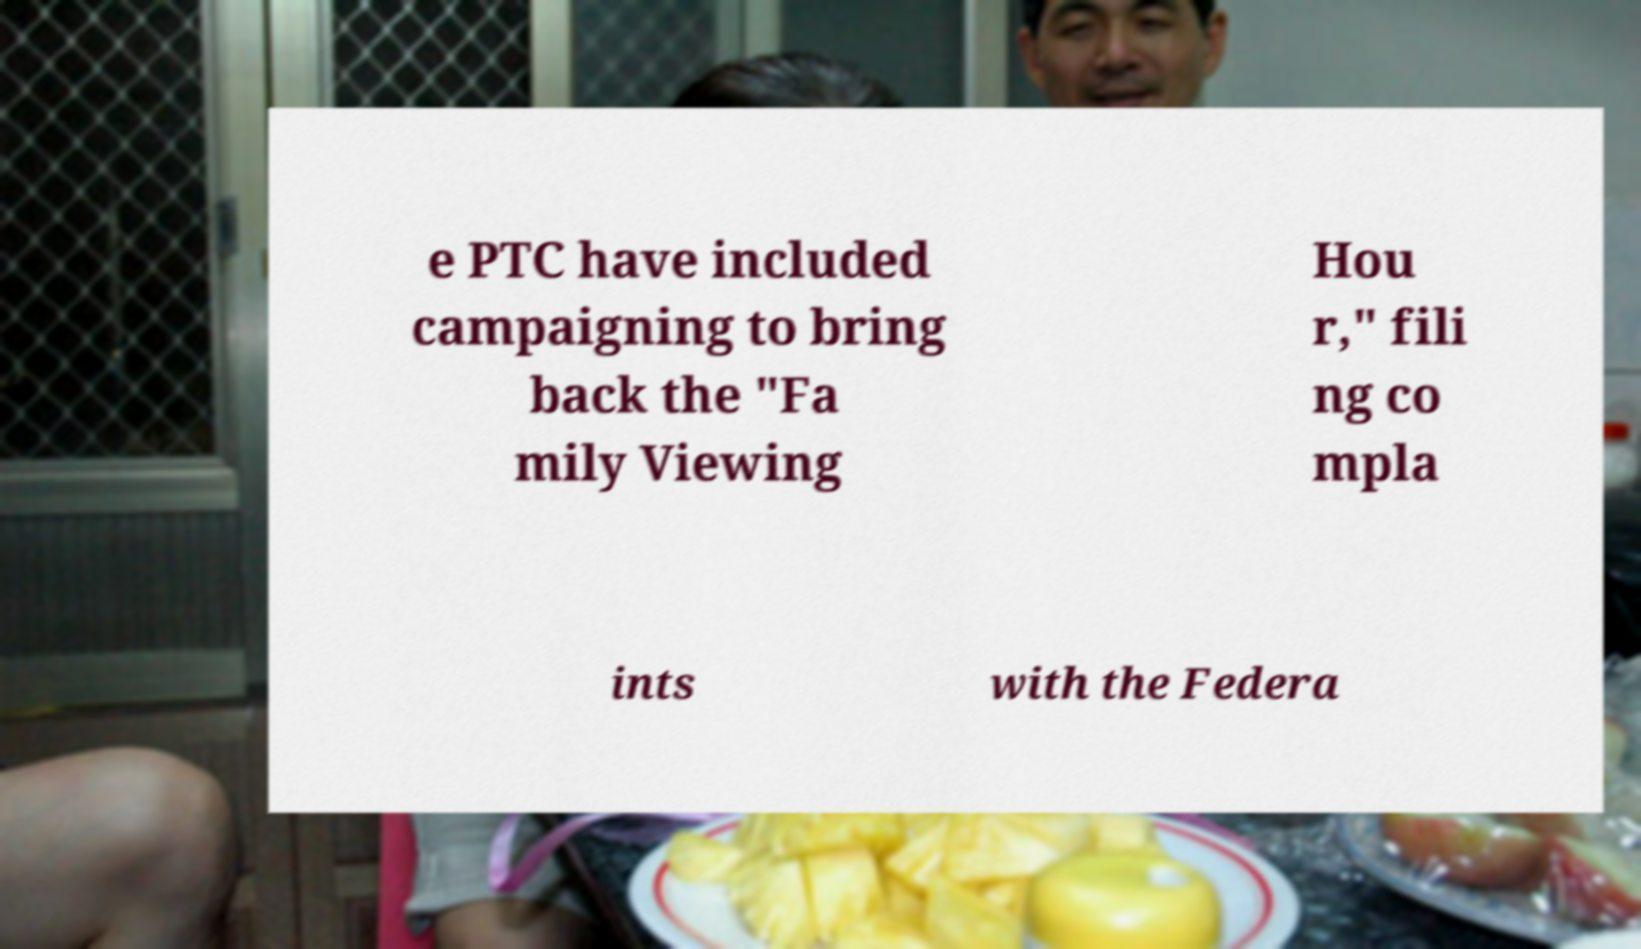What messages or text are displayed in this image? I need them in a readable, typed format. e PTC have included campaigning to bring back the "Fa mily Viewing Hou r," fili ng co mpla ints with the Federa 